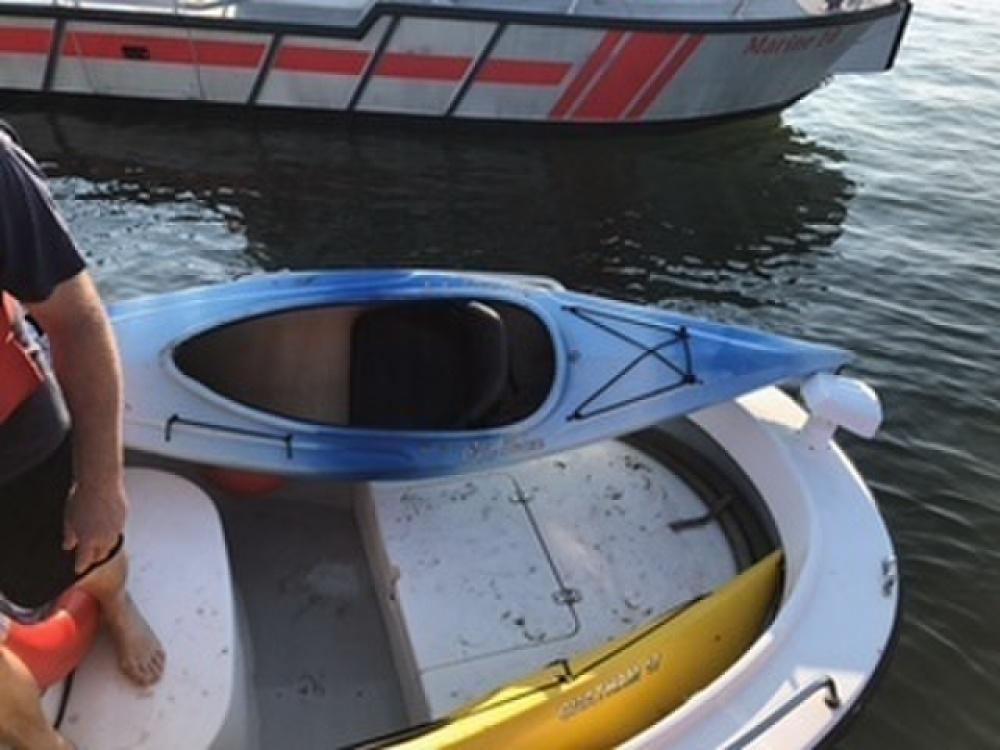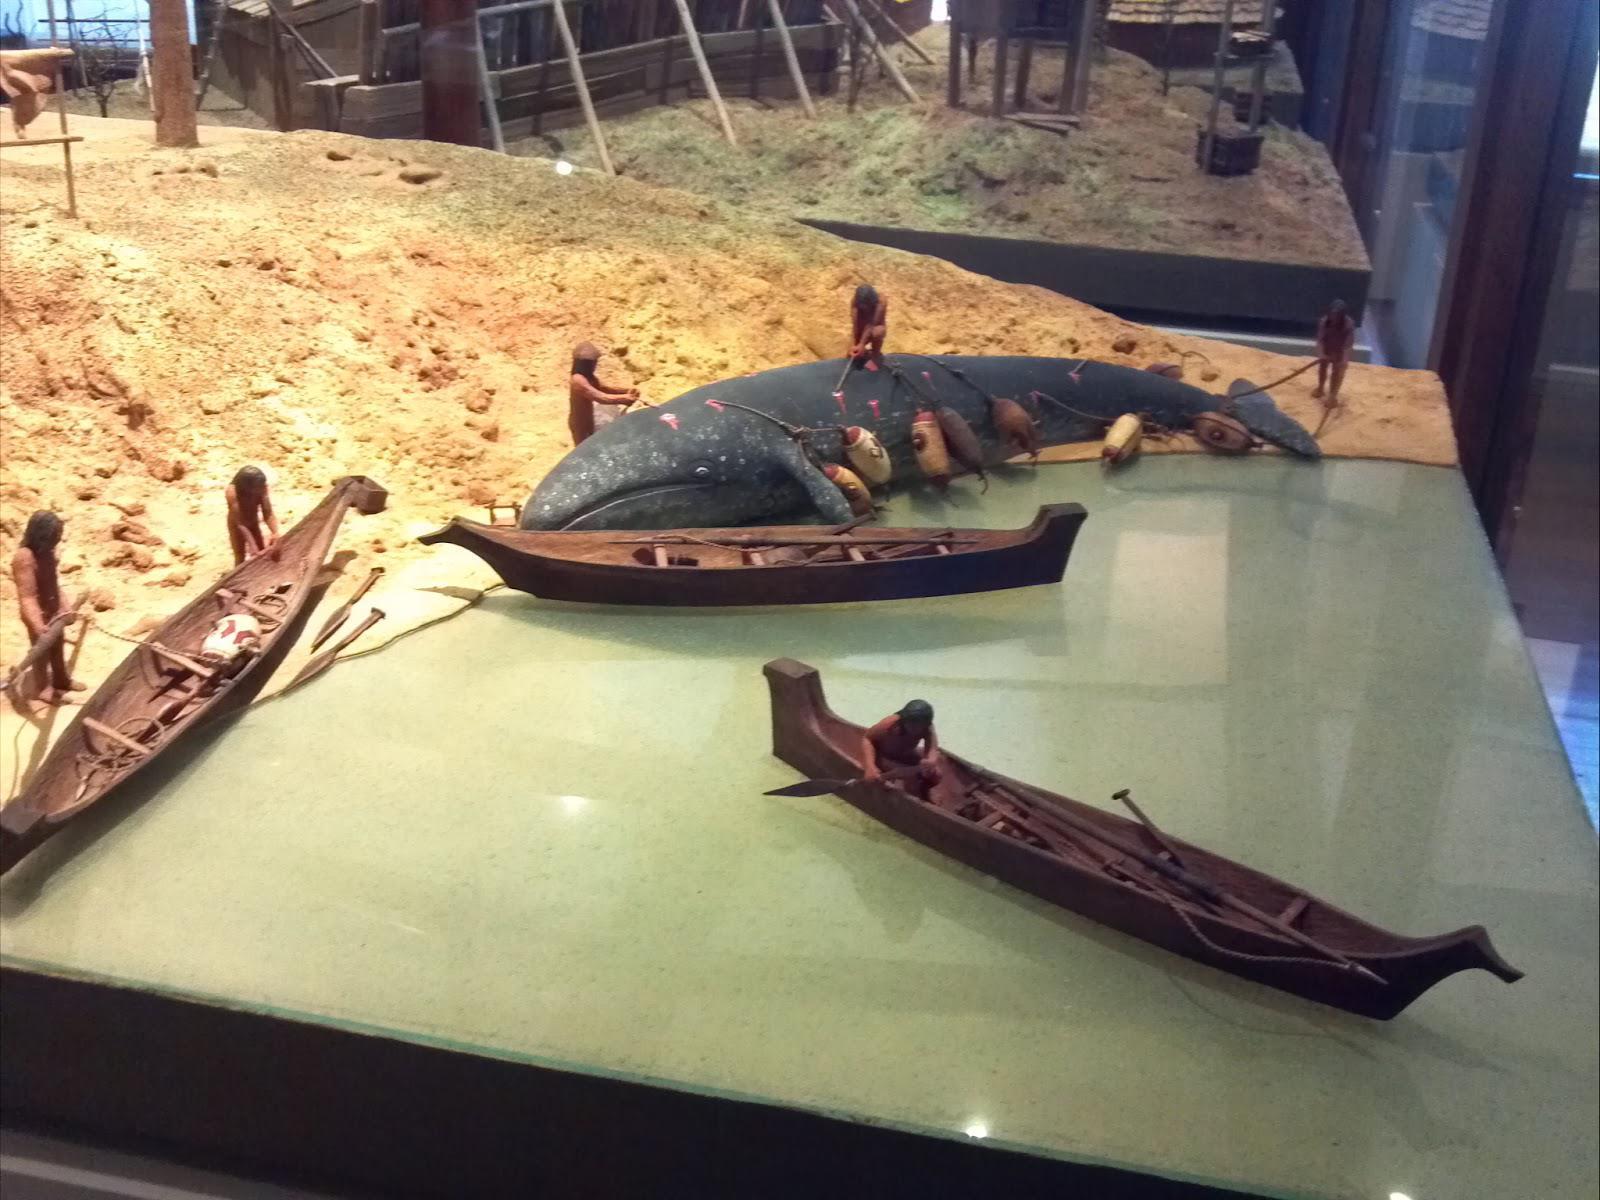The first image is the image on the left, the second image is the image on the right. Evaluate the accuracy of this statement regarding the images: "There is at least one green canoe visible". Is it true? Answer yes or no. No. 